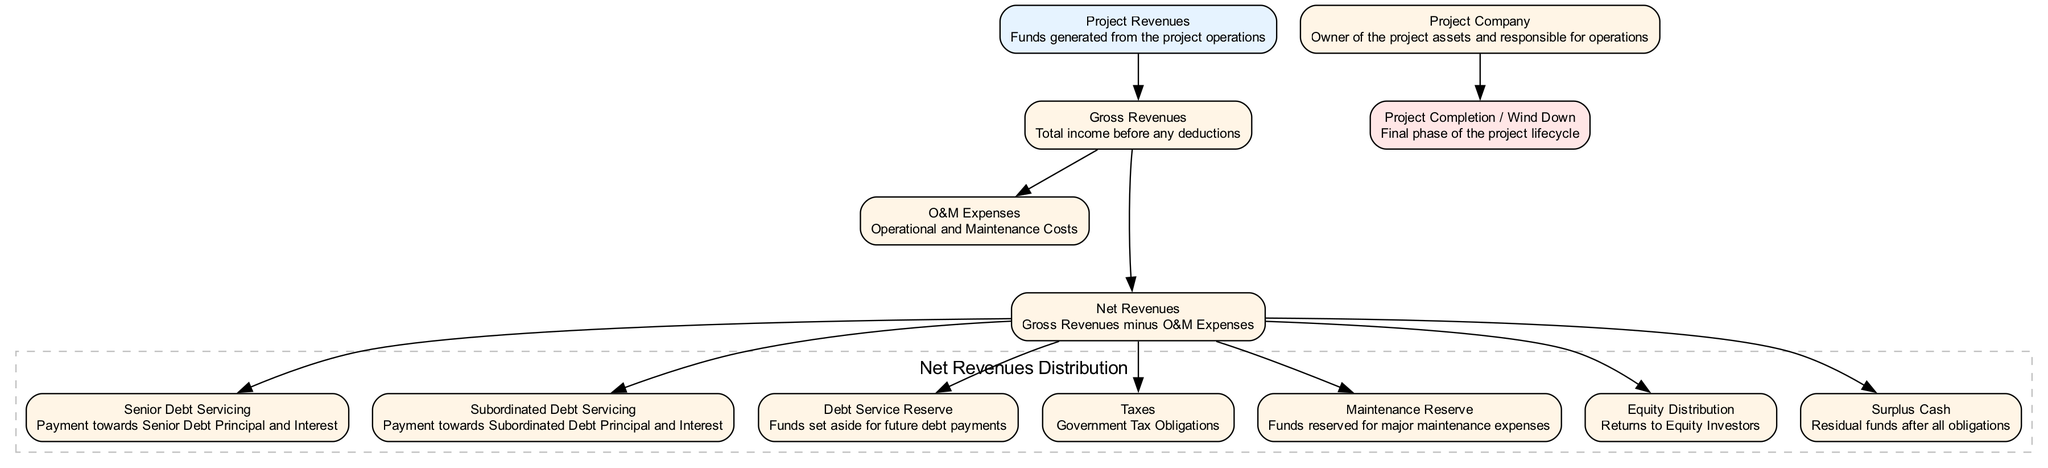What is the starting point of the Cash Flow Waterfall Structure? The starting point of the diagram is "Project Revenues," which signifies the funds generated from the project operations.
Answer: Project Revenues How many nodes are present in the diagram? By counting the nodes, we see there are 11 nodes in total, including the start and end nodes.
Answer: 11 Which node comes immediately after "Gross Revenues"? The node that comes immediately after "Gross Revenues" is "O&M Expenses," as indicated by the directed edge connecting them.
Answer: O&M Expenses What is the last node in the Cash Flow Waterfall Structure? The last node in the diagram, indicating the completion of the project lifecycle, is "Project Completion / Wind Down."
Answer: Project Completion / Wind Down What are the first five nodes that derive from "Net Revenues"? The first five nodes that derive from "Net Revenues" are "Senior Debt Servicing," "Subordinated Debt Servicing," "Debt Service Reserve," "Taxes," and "Maintenance Reserve."
Answer: Senior Debt Servicing, Subordinated Debt Servicing, Debt Service Reserve, Taxes, Maintenance Reserve Which distribution is represented in the dashed subgraph? The dashed subgraph represents "Net Revenues Distribution," which signifies how net revenues are allocated towards different obligations.
Answer: Net Revenues Distribution How many types of debt servicing are shown in the diagram? The diagram illustrates two types of debt servicing: "Senior Debt Servicing" and "Subordinated Debt Servicing."
Answer: Two What type of expenses are deducted to arrive at Net Revenues? The type of expenses deducted to arrive at Net Revenues are "O&M Expenses," which are the operational and maintenance costs of the project.
Answer: O&M Expenses What does "Surplus Cash" represent in the context of the diagram? "Surplus Cash" represents the residual funds available after all obligations have been addressed in the cash flow waterfall.
Answer: Surplus Cash 